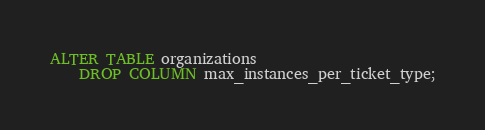Convert code to text. <code><loc_0><loc_0><loc_500><loc_500><_SQL_>ALTER TABLE organizations
    DROP COLUMN max_instances_per_ticket_type;</code> 